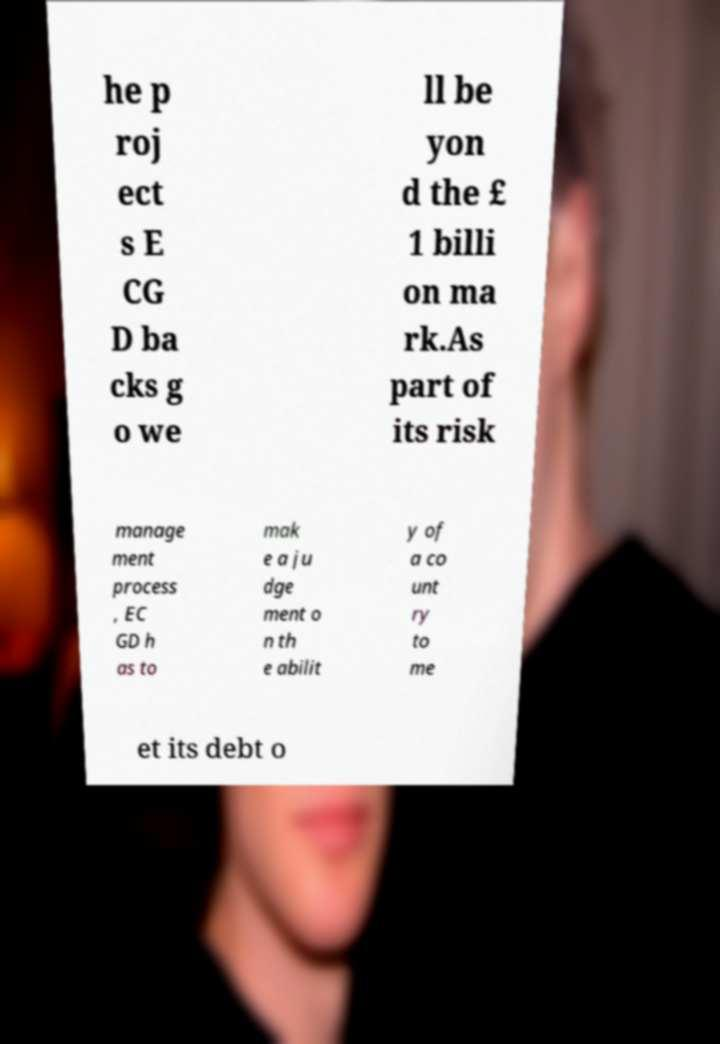There's text embedded in this image that I need extracted. Can you transcribe it verbatim? he p roj ect s E CG D ba cks g o we ll be yon d the £ 1 billi on ma rk.As part of its risk manage ment process , EC GD h as to mak e a ju dge ment o n th e abilit y of a co unt ry to me et its debt o 